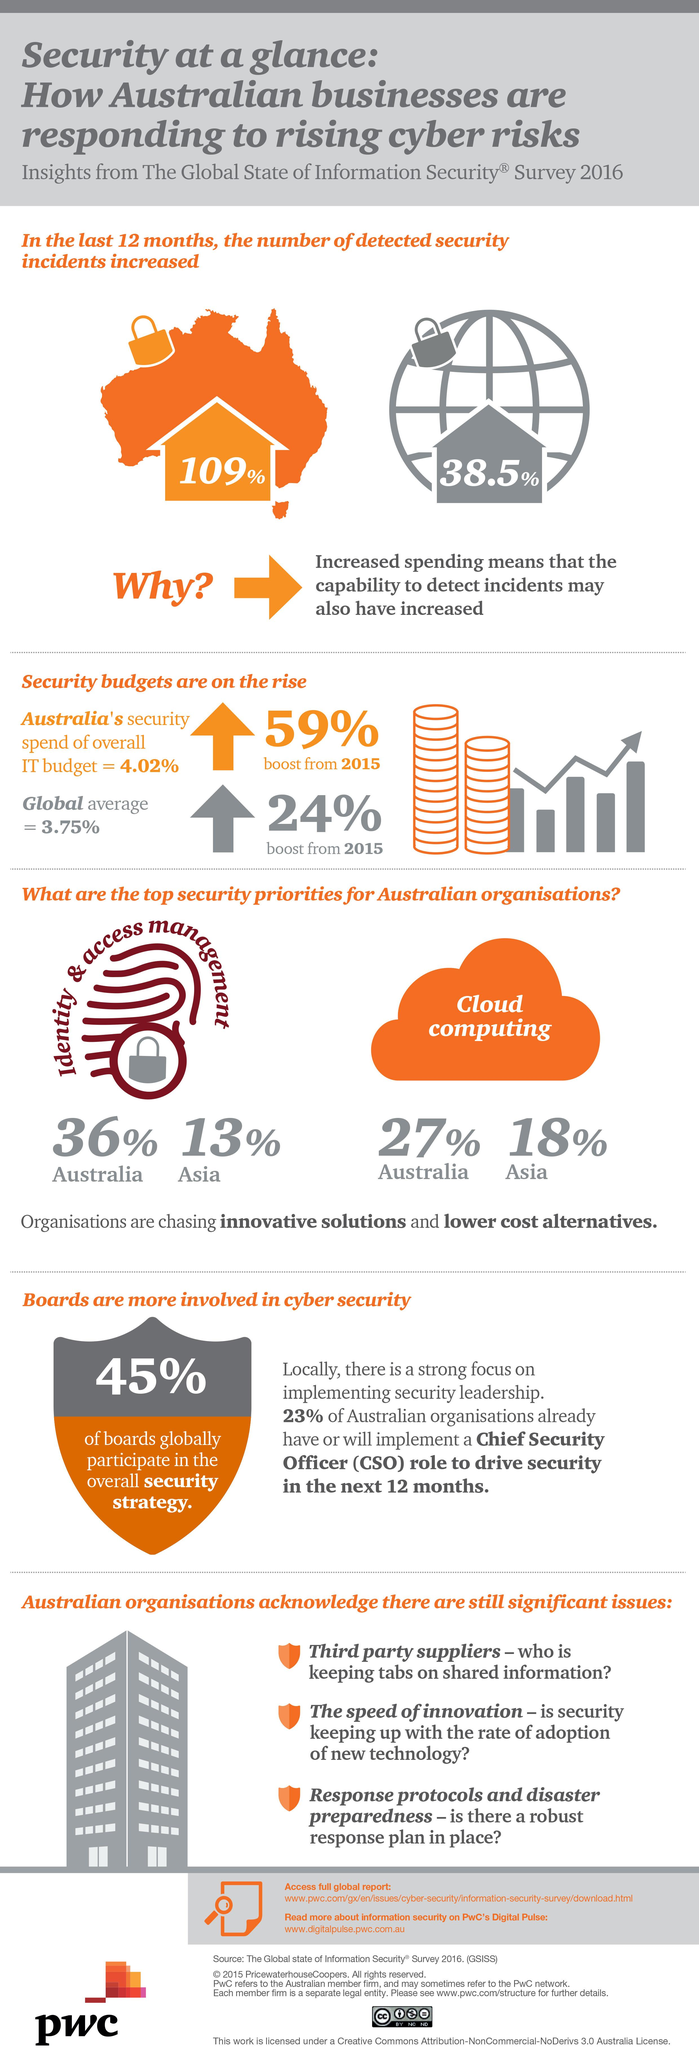Outline some significant characteristics in this image. The top priorities in security for Australian companies are identity and access management and cloud computing. The percentage difference in Australians and Asians opting for Identity & Access Management is 23%. A recent study found that the percentage of Australians and Asians who choose to use cloud computing is 9%. 